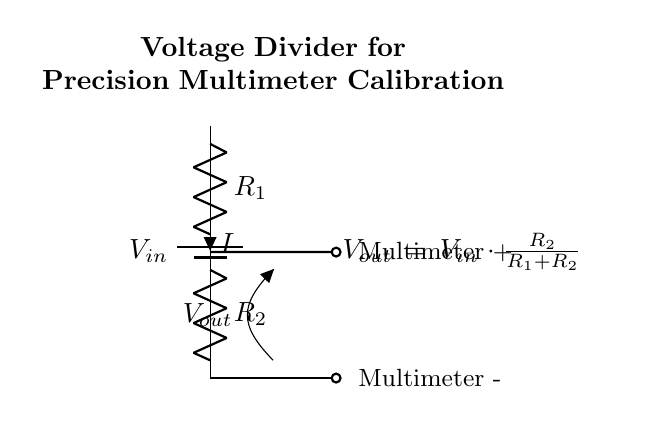What is the input voltage in this circuit? The input voltage, labeled as V_in, represents the source of electrical potential applied to the voltage divider. It is drawn at the top of the circuit diagram, positioned next to the battery symbol.
Answer: V_in What type of circuit is this? This is a voltage divider circuit which consists of two resistors arranged in series, allowing for the division of an input voltage to produce a smaller output voltage.
Answer: Voltage divider What are the names of the resistors in this circuit? The resistors are labeled as R_1 and R_2. This information is directly evident from the circuit diagram where each resistor is represented with its respective label.
Answer: R_1 and R_2 What is the formula for output voltage in this circuit? The formula for output voltage (V_out) is given in the diagram as V_out = V_in * (R_2 / (R_1 + R_2)). This is located next to the diagram and is critical for understanding the voltage division of the circuit.
Answer: V_out = V_in * (R_2 / (R_1 + R_2)) What is V_out when R_1 equals 1k ohm and R_2 equals 2k ohm with an input of 9V? To calculate V_out, substitute R_1 = 1k ohm and R_2 = 2k ohm into the formula: V_out = 9V * (2k / (1k + 2k)) = 9V * (2/3) = 6V. This is a straightforward calculation using the voltage divider equation provided.
Answer: 6V What is the direction of current flow in this circuit? The direction of current flow, denoted by the label I, is from the higher potential at the input (V_in) downward through the resistors to the lower potential. This flows through R_1 first, then R_2, and finally to ground.
Answer: Downward 